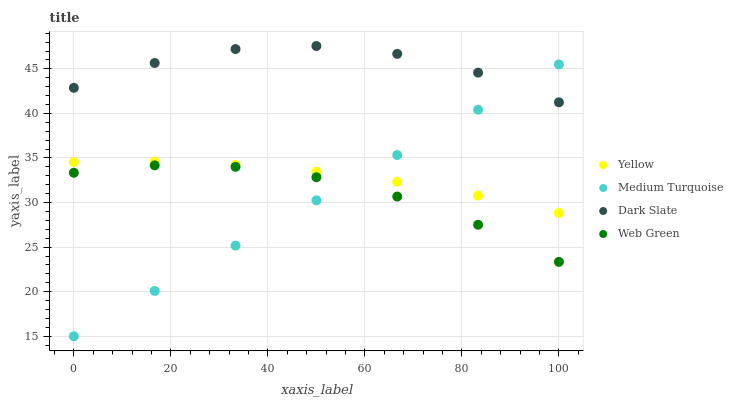Does Medium Turquoise have the minimum area under the curve?
Answer yes or no. Yes. Does Dark Slate have the maximum area under the curve?
Answer yes or no. Yes. Does Web Green have the minimum area under the curve?
Answer yes or no. No. Does Web Green have the maximum area under the curve?
Answer yes or no. No. Is Medium Turquoise the smoothest?
Answer yes or no. Yes. Is Dark Slate the roughest?
Answer yes or no. Yes. Is Web Green the smoothest?
Answer yes or no. No. Is Web Green the roughest?
Answer yes or no. No. Does Medium Turquoise have the lowest value?
Answer yes or no. Yes. Does Web Green have the lowest value?
Answer yes or no. No. Does Dark Slate have the highest value?
Answer yes or no. Yes. Does Medium Turquoise have the highest value?
Answer yes or no. No. Is Web Green less than Yellow?
Answer yes or no. Yes. Is Yellow greater than Web Green?
Answer yes or no. Yes. Does Medium Turquoise intersect Web Green?
Answer yes or no. Yes. Is Medium Turquoise less than Web Green?
Answer yes or no. No. Is Medium Turquoise greater than Web Green?
Answer yes or no. No. Does Web Green intersect Yellow?
Answer yes or no. No. 